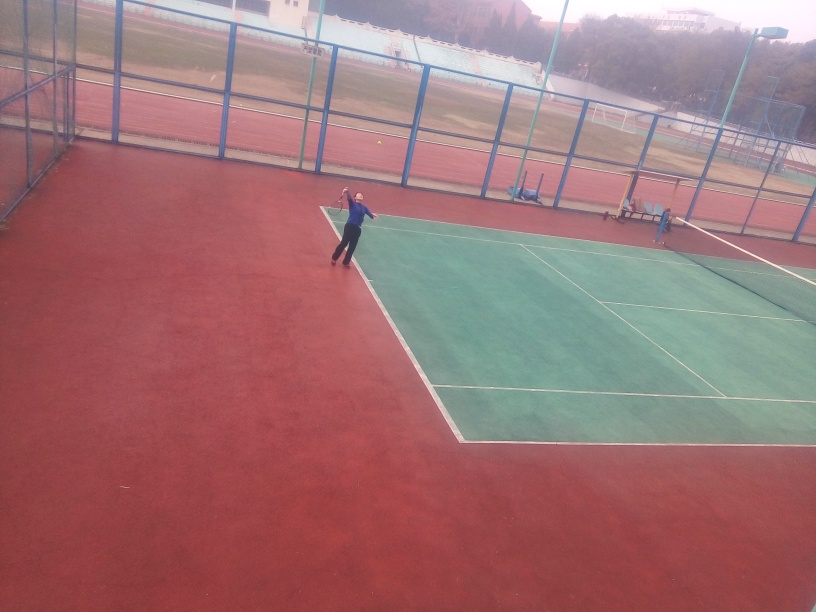How would you describe the activity taking place in this image? The image captures two individuals engaged in a game of tennis, one of whom can be seen in the foreground ready to serve the ball. The tennis court's green surface and red surrounds suggest this is likely an outdoor recreational facility. What time of day or weather conditions does it seem to be? Given the diffused lighting and lack of deep shadows on the court, it seems to be an overcast day. The courts are well-lit by natural light, indicating that it's daytime, although the exact time cannot be determined. 